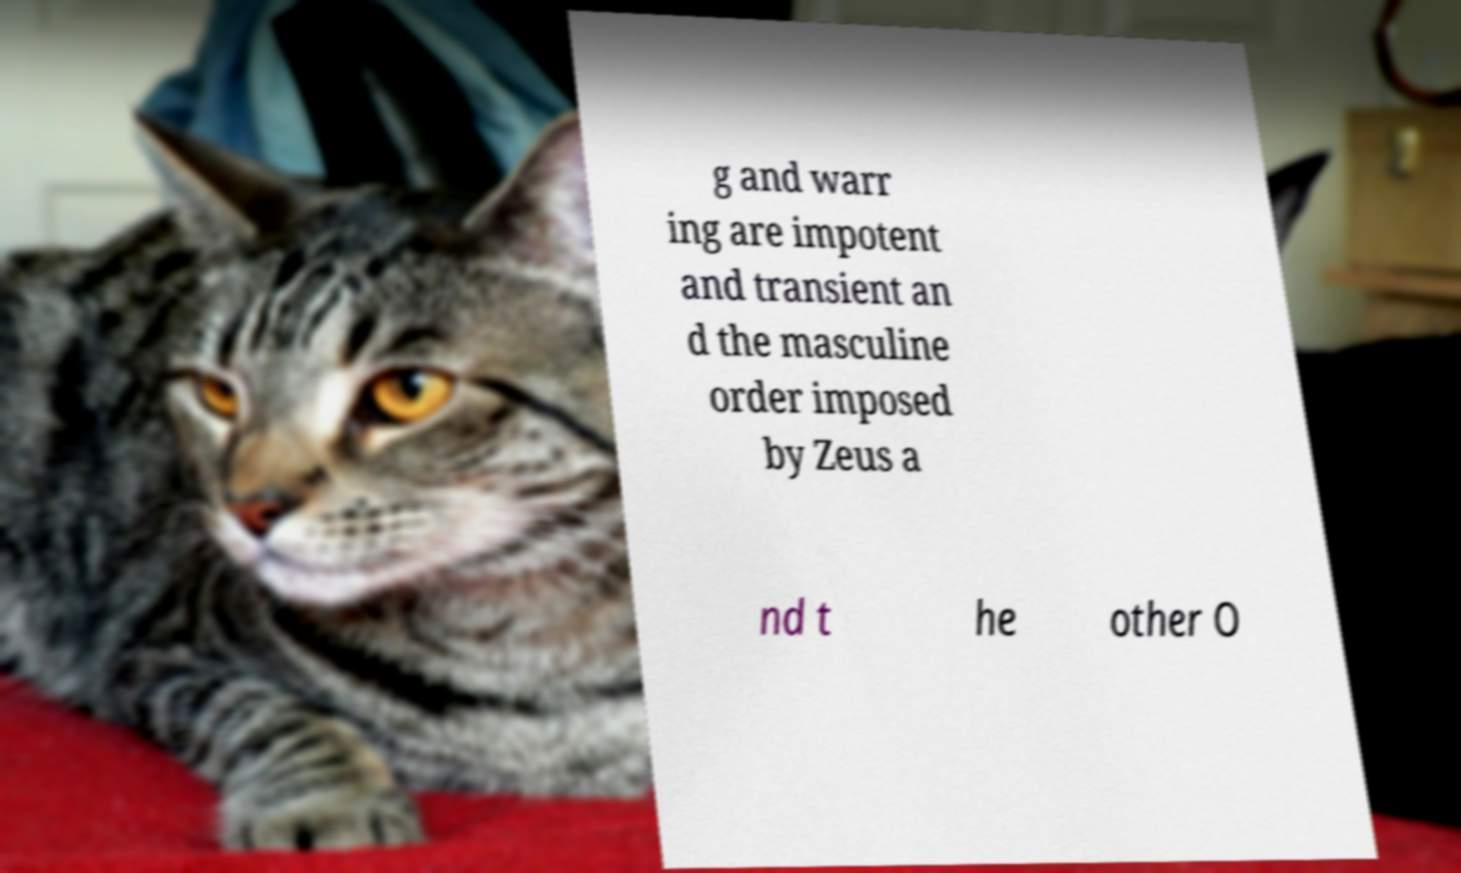Could you extract and type out the text from this image? g and warr ing are impotent and transient an d the masculine order imposed by Zeus a nd t he other O 